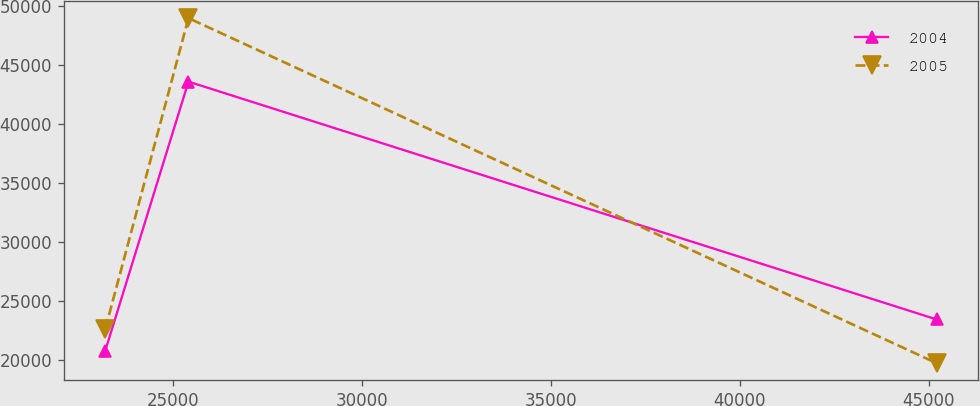Convert chart to OTSL. <chart><loc_0><loc_0><loc_500><loc_500><line_chart><ecel><fcel>2004<fcel>2005<nl><fcel>23219.8<fcel>20810.4<fcel>22660.2<nl><fcel>25418.8<fcel>43562.3<fcel>48938.9<nl><fcel>45210.3<fcel>23440.9<fcel>19740.4<nl></chart> 